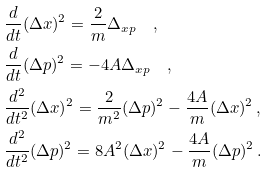<formula> <loc_0><loc_0><loc_500><loc_500>& \frac { d } { d t } ( \Delta x ) ^ { 2 } = \frac { 2 } { m } \Delta _ { x p } \quad , \\ & \frac { d } { d t } ( \Delta p ) ^ { 2 } = - 4 A \Delta _ { x p } \quad , \\ & \frac { d ^ { 2 } } { d t ^ { 2 } } ( \Delta x ) ^ { 2 } = \frac { 2 } { m ^ { 2 } } ( \Delta p ) ^ { 2 } - \frac { 4 A } { m } ( \Delta x ) ^ { 2 } \, , \\ & \frac { d ^ { 2 } } { d t ^ { 2 } } ( \Delta p ) ^ { 2 } = 8 A ^ { 2 } ( \Delta x ) ^ { 2 } - \frac { 4 A } { m } ( \Delta p ) ^ { 2 } \, .</formula> 